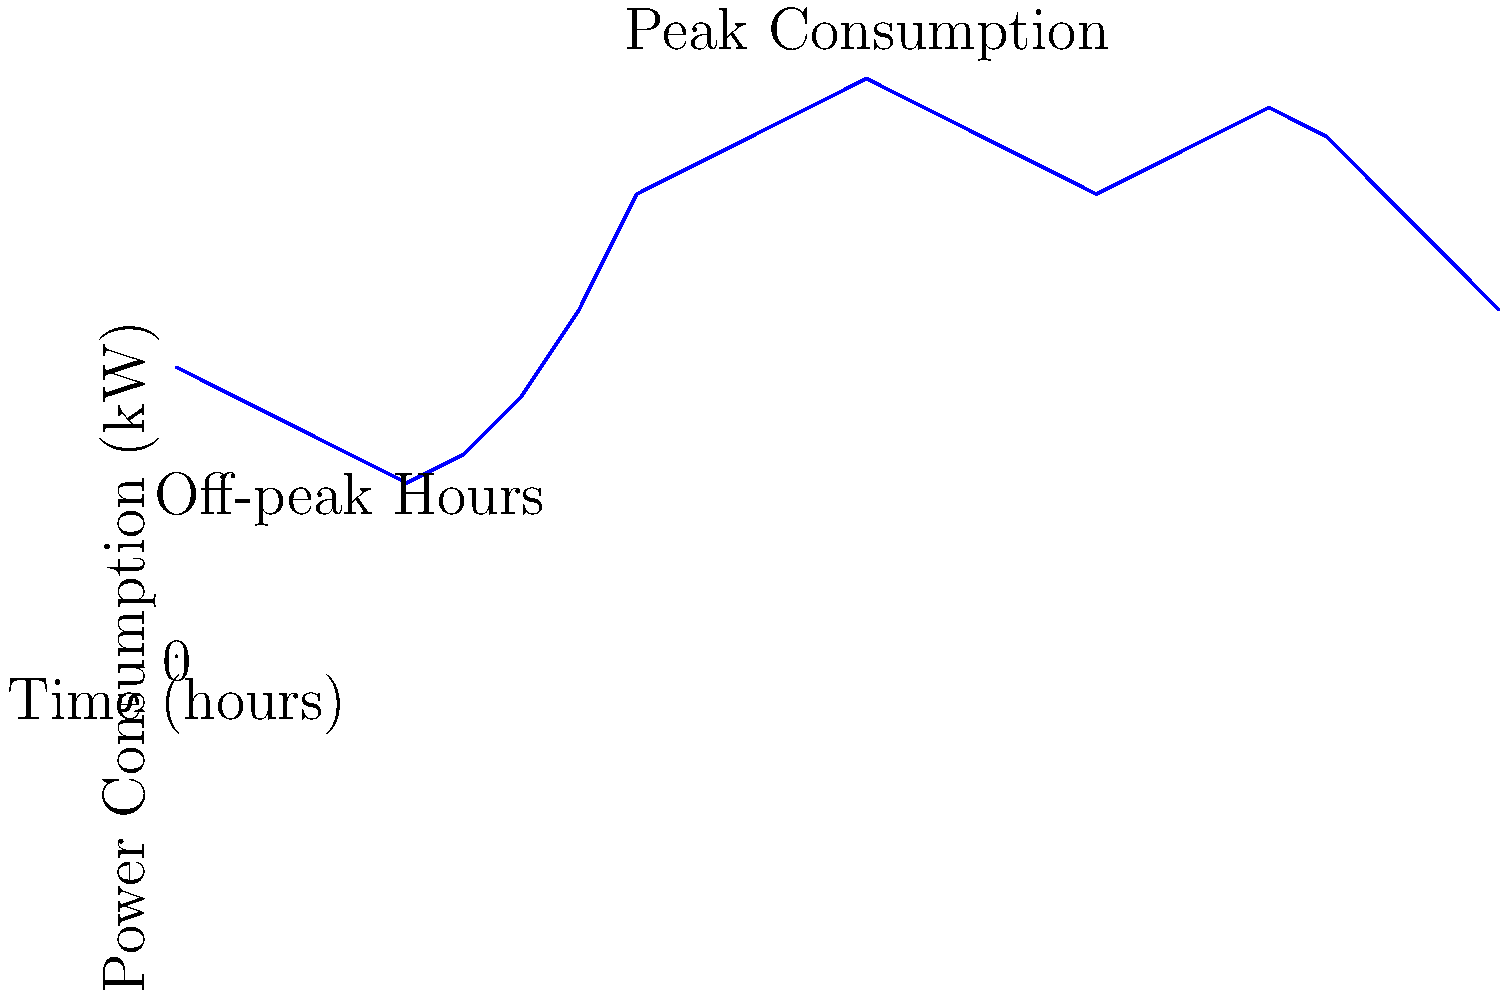Based on the time-series graph of power consumption in a corporate building over a 24-hour period, what is the difference in kilowatts (kW) between the peak consumption and the lowest consumption? Additionally, during which hour does the peak consumption occur? To answer this question, we need to analyze the time-series graph carefully:

1. Identify the peak consumption:
   - The highest point on the graph is at 100 kW.
   - This occurs at the 12-hour mark (noon).

2. Identify the lowest consumption:
   - The lowest point on the graph is at 30 kW.
   - This occurs at the 4-hour mark (4 AM).

3. Calculate the difference between peak and lowest consumption:
   $100 \text{ kW} - 30 \text{ kW} = 70 \text{ kW}$

4. Determine the hour of peak consumption:
   - The peak occurs at the 12-hour mark, which corresponds to 12 PM (noon).

Therefore, the difference between peak and lowest consumption is 70 kW, and the peak consumption occurs at 12 PM (noon).
Answer: 70 kW; 12 PM 